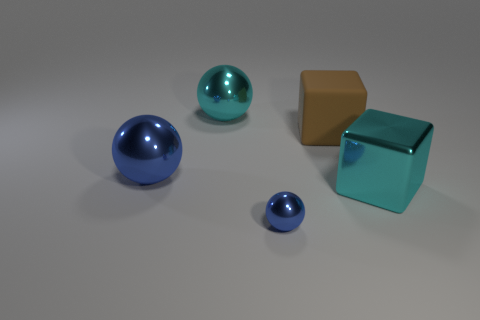Add 4 big gray metal spheres. How many objects exist? 9 Subtract all spheres. How many objects are left? 2 Subtract 0 purple cubes. How many objects are left? 5 Subtract all small metal things. Subtract all tiny brown rubber cylinders. How many objects are left? 4 Add 2 brown blocks. How many brown blocks are left? 3 Add 2 small purple matte objects. How many small purple matte objects exist? 2 